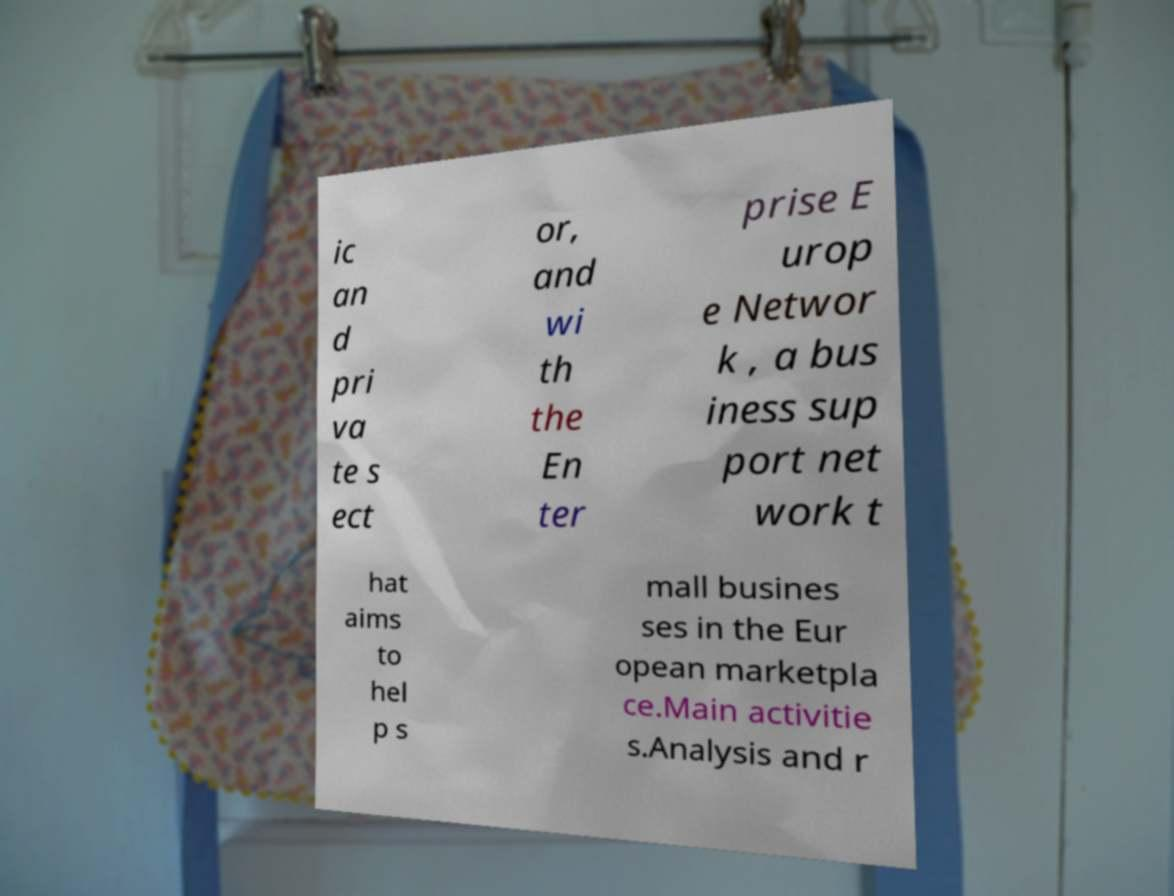Could you assist in decoding the text presented in this image and type it out clearly? ic an d pri va te s ect or, and wi th the En ter prise E urop e Networ k , a bus iness sup port net work t hat aims to hel p s mall busines ses in the Eur opean marketpla ce.Main activitie s.Analysis and r 